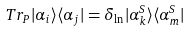<formula> <loc_0><loc_0><loc_500><loc_500>T r _ { P } | \alpha _ { i } \rangle \langle \alpha _ { j } | = \delta _ { \ln } | \alpha _ { k } ^ { S } \rangle \langle \alpha _ { m } ^ { S } |</formula> 